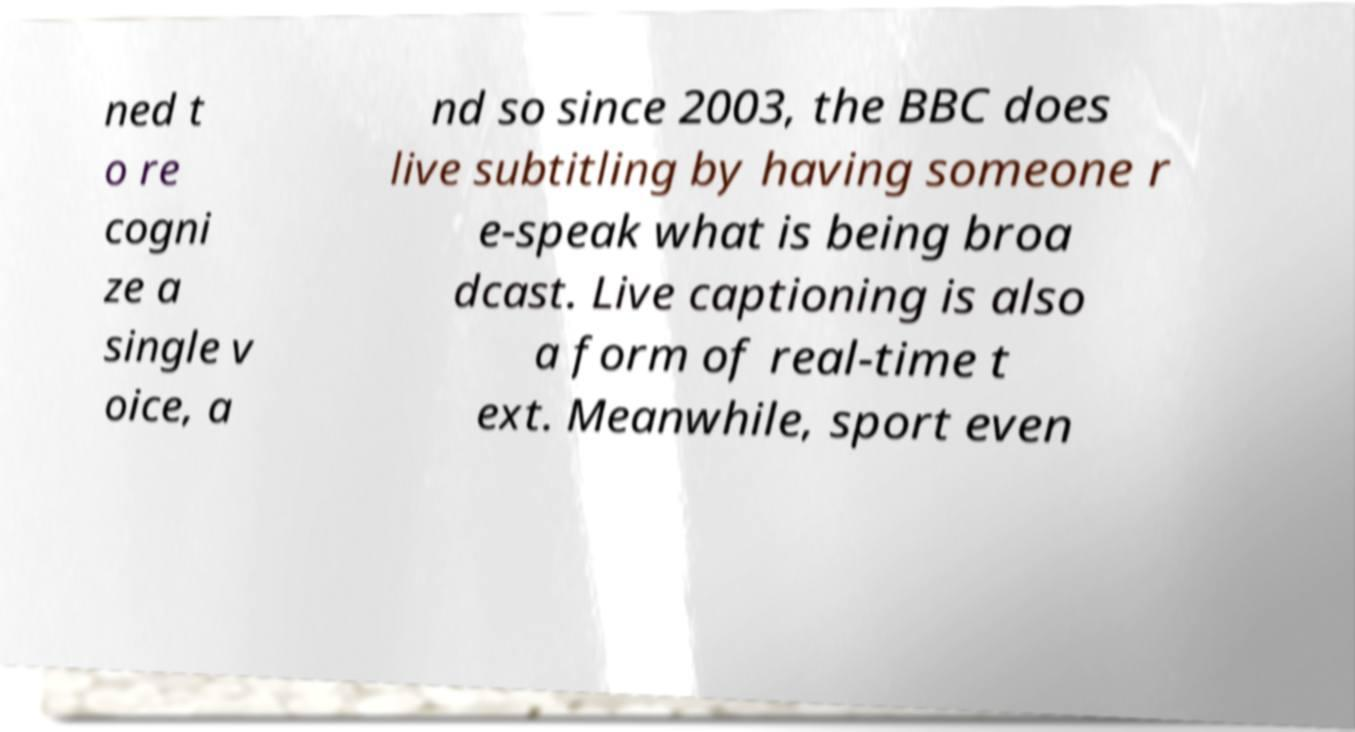I need the written content from this picture converted into text. Can you do that? ned t o re cogni ze a single v oice, a nd so since 2003, the BBC does live subtitling by having someone r e-speak what is being broa dcast. Live captioning is also a form of real-time t ext. Meanwhile, sport even 